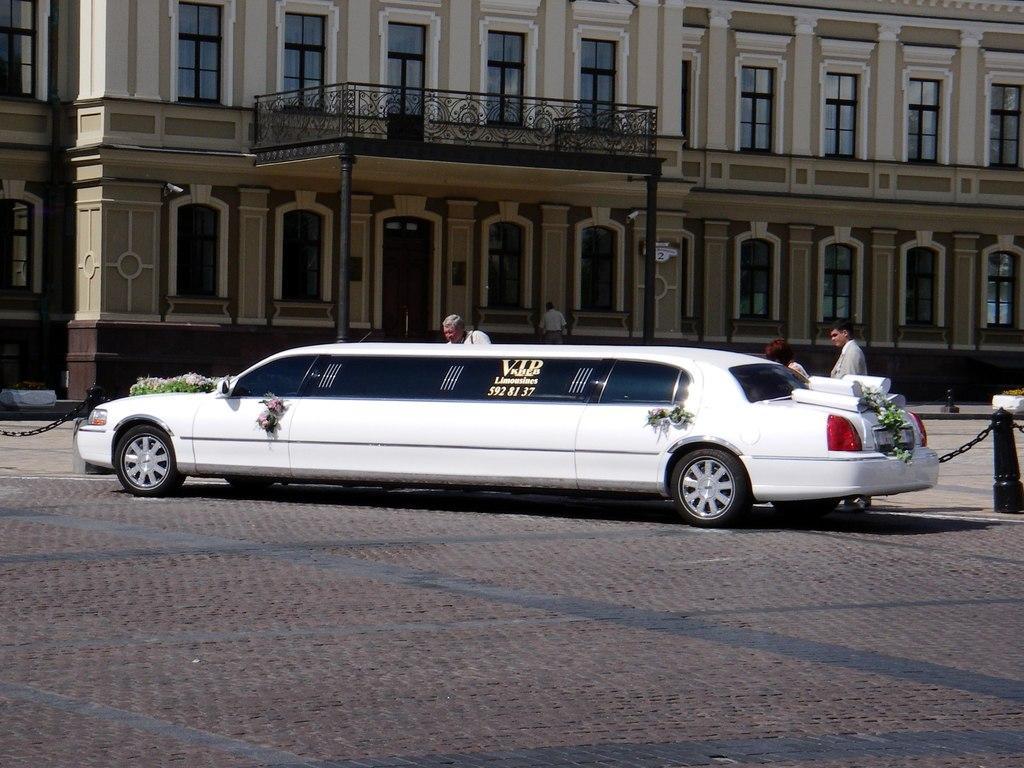Describe this image in one or two sentences. In this picture I can see a car and few persons in the middle, in the background there is a building. There are chains on either side of this image. 